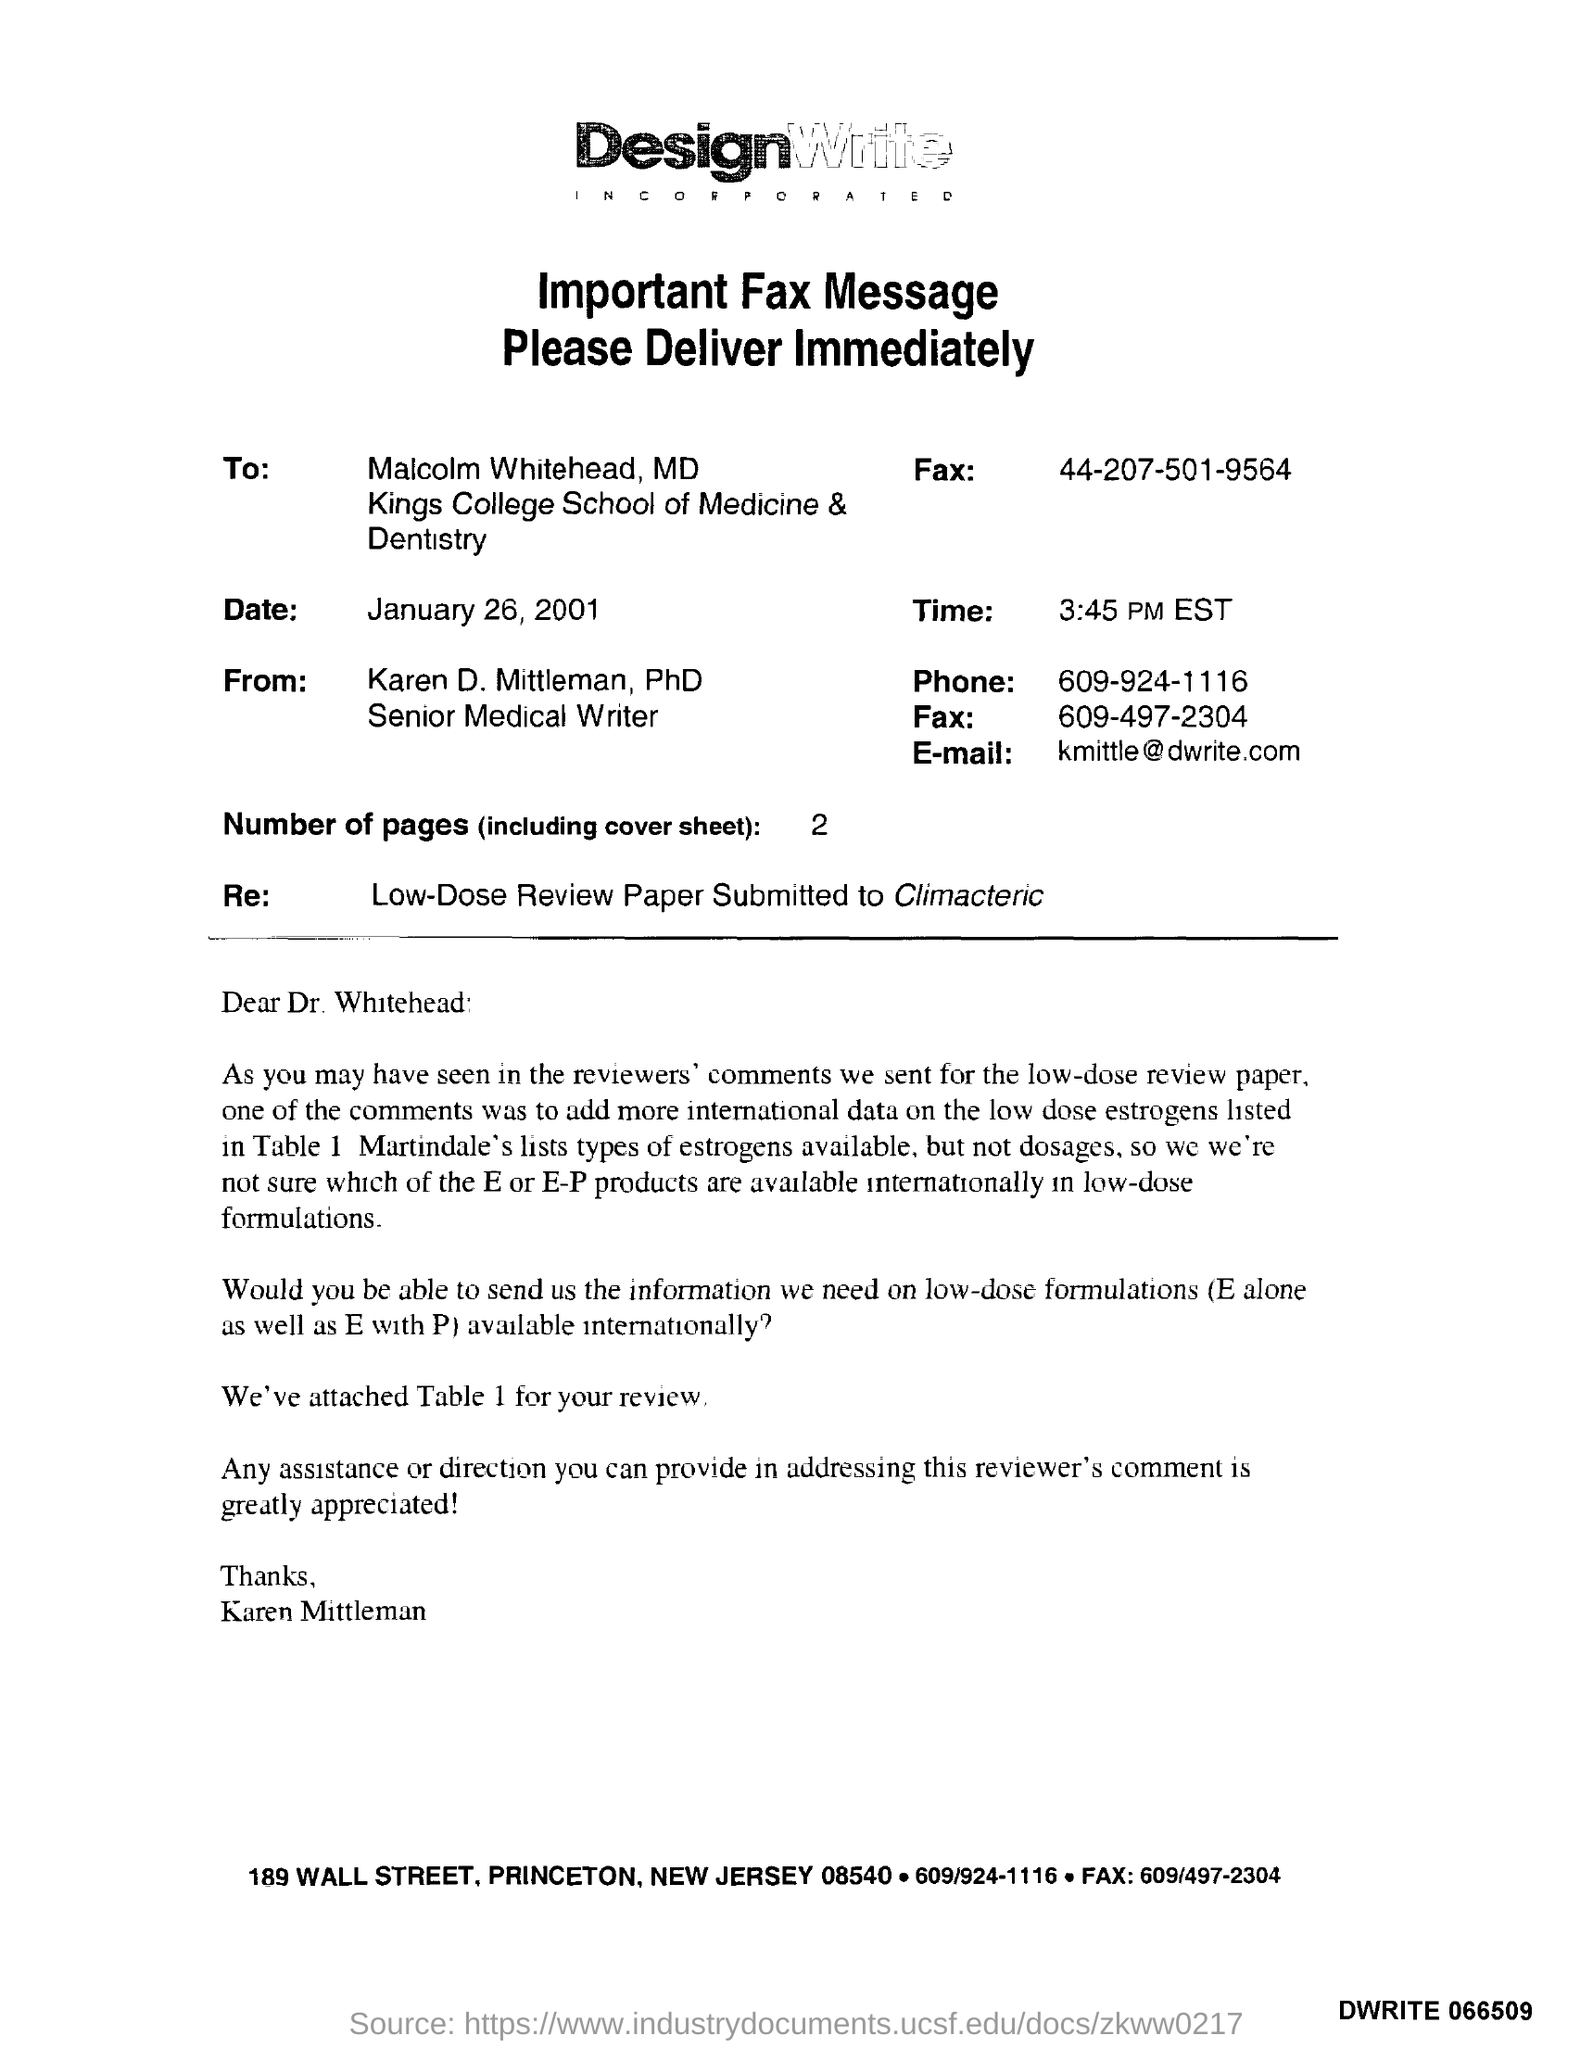Highlight a few significant elements in this photo. The fax message was delivered to Karen D. Mittleman, Ph.D. The recipient of the fax was Malcolm Whitehead. The phone number mentioned in the fax is 609-924-1116. The date mentioned in the fax message is January 26, 2001. The time mentioned in the given fax message is 3:45 PM EST. 